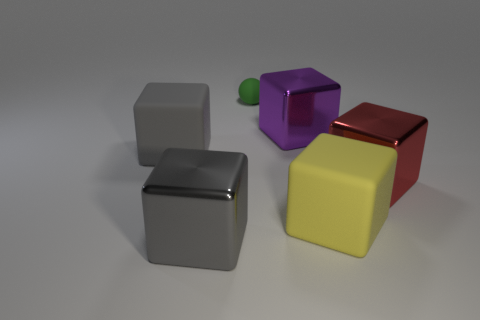Subtract all purple cubes. How many cubes are left? 4 Subtract all red cubes. How many cubes are left? 4 Subtract 1 cubes. How many cubes are left? 4 Subtract all cyan blocks. Subtract all brown cylinders. How many blocks are left? 5 Add 2 tiny purple metallic cubes. How many objects exist? 8 Subtract all spheres. How many objects are left? 5 Subtract all big red matte blocks. Subtract all big matte blocks. How many objects are left? 4 Add 5 gray things. How many gray things are left? 7 Add 1 large red cubes. How many large red cubes exist? 2 Subtract 0 brown cylinders. How many objects are left? 6 